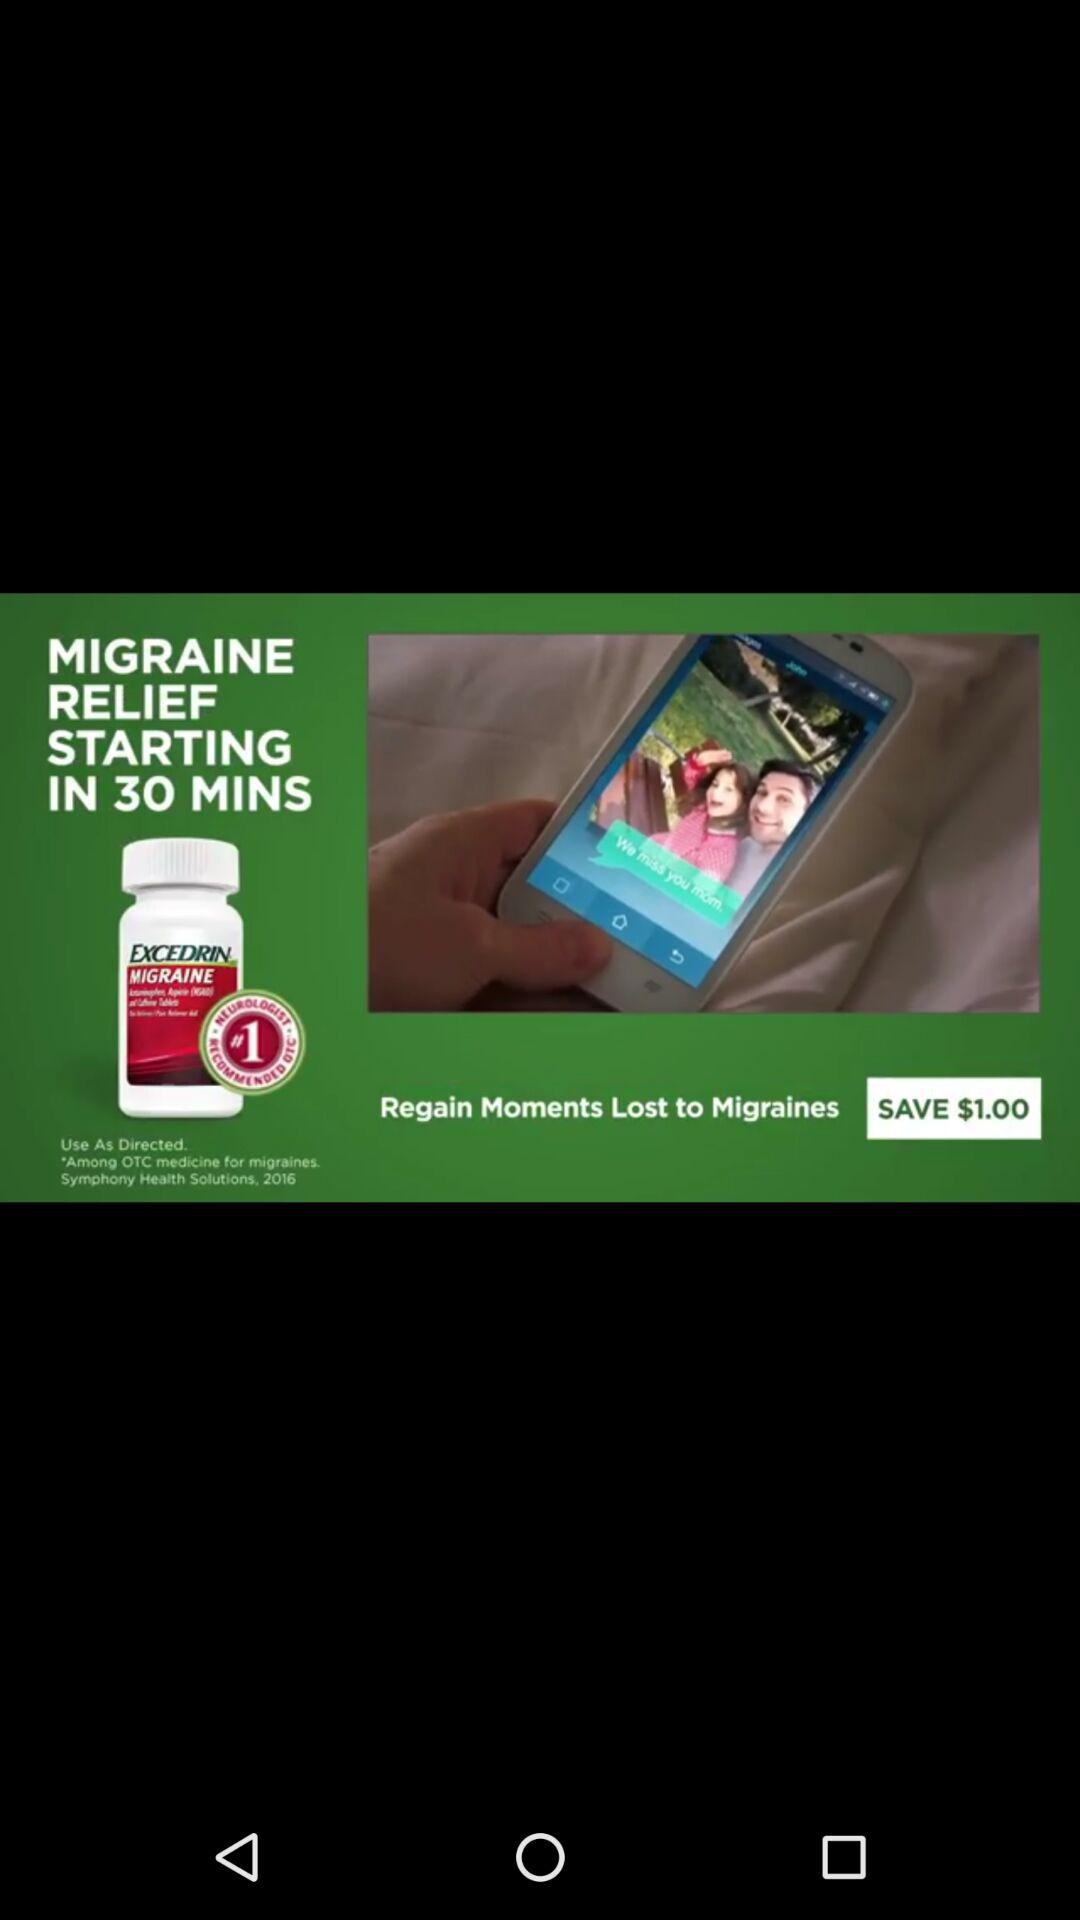How much do you save? You can save $1.00. 